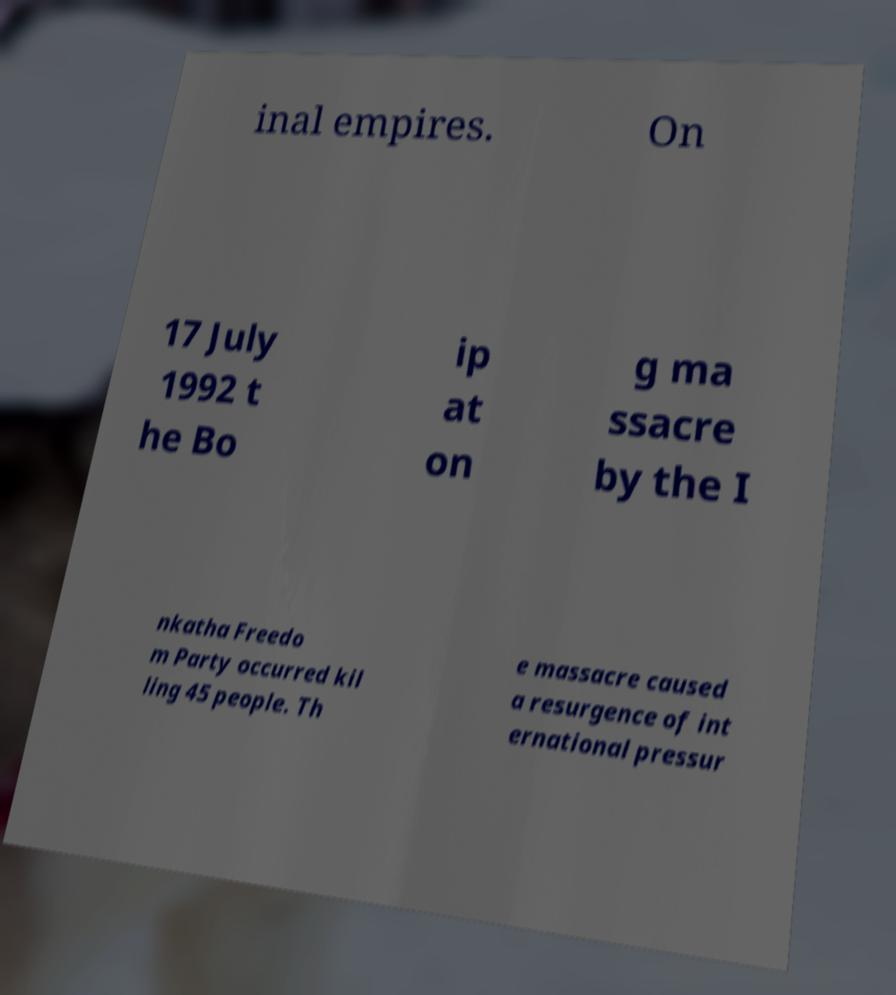Can you accurately transcribe the text from the provided image for me? inal empires. On 17 July 1992 t he Bo ip at on g ma ssacre by the I nkatha Freedo m Party occurred kil ling 45 people. Th e massacre caused a resurgence of int ernational pressur 